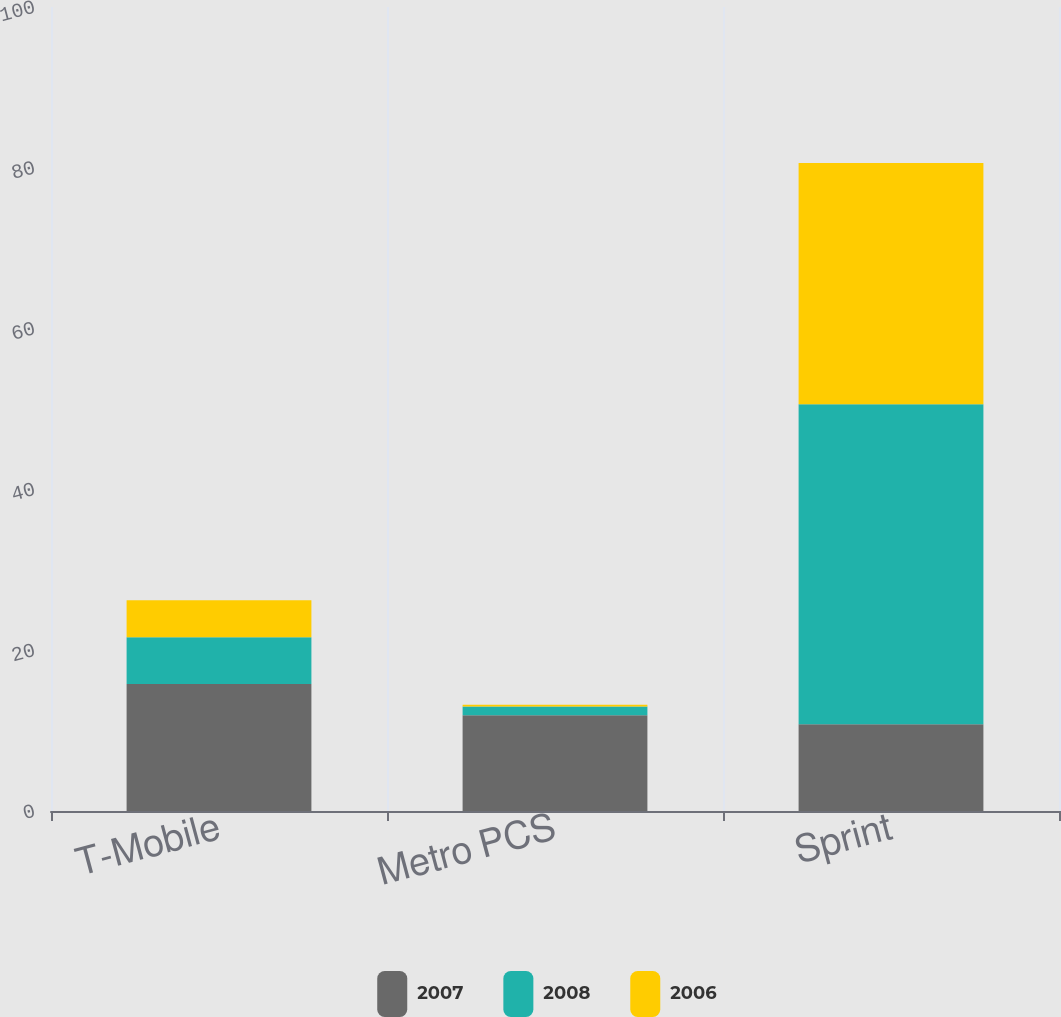Convert chart. <chart><loc_0><loc_0><loc_500><loc_500><stacked_bar_chart><ecel><fcel>T-Mobile<fcel>Metro PCS<fcel>Sprint<nl><fcel>2007<fcel>15.8<fcel>11.9<fcel>10.8<nl><fcel>2008<fcel>5.8<fcel>1.1<fcel>39.8<nl><fcel>2006<fcel>4.6<fcel>0.2<fcel>30<nl></chart> 